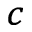Convert formula to latex. <formula><loc_0><loc_0><loc_500><loc_500>_ { c }</formula> 